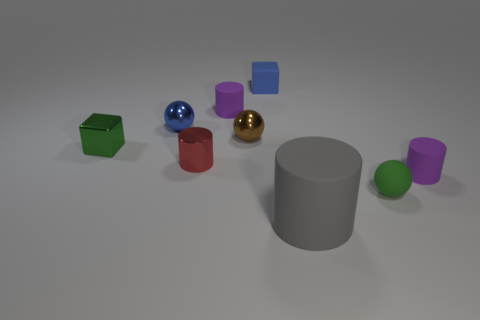Subtract all gray cylinders. How many cylinders are left? 3 Subtract all gray rubber cylinders. How many cylinders are left? 3 Subtract all brown cylinders. Subtract all purple balls. How many cylinders are left? 4 Add 1 yellow shiny blocks. How many objects exist? 10 Subtract all spheres. How many objects are left? 6 Add 5 small metallic cylinders. How many small metallic cylinders exist? 6 Subtract 0 green cylinders. How many objects are left? 9 Subtract all big things. Subtract all green metallic objects. How many objects are left? 7 Add 7 brown objects. How many brown objects are left? 8 